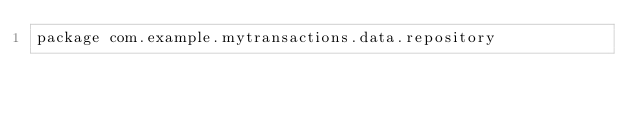<code> <loc_0><loc_0><loc_500><loc_500><_Kotlin_>package com.example.mytransactions.data.repository
</code> 